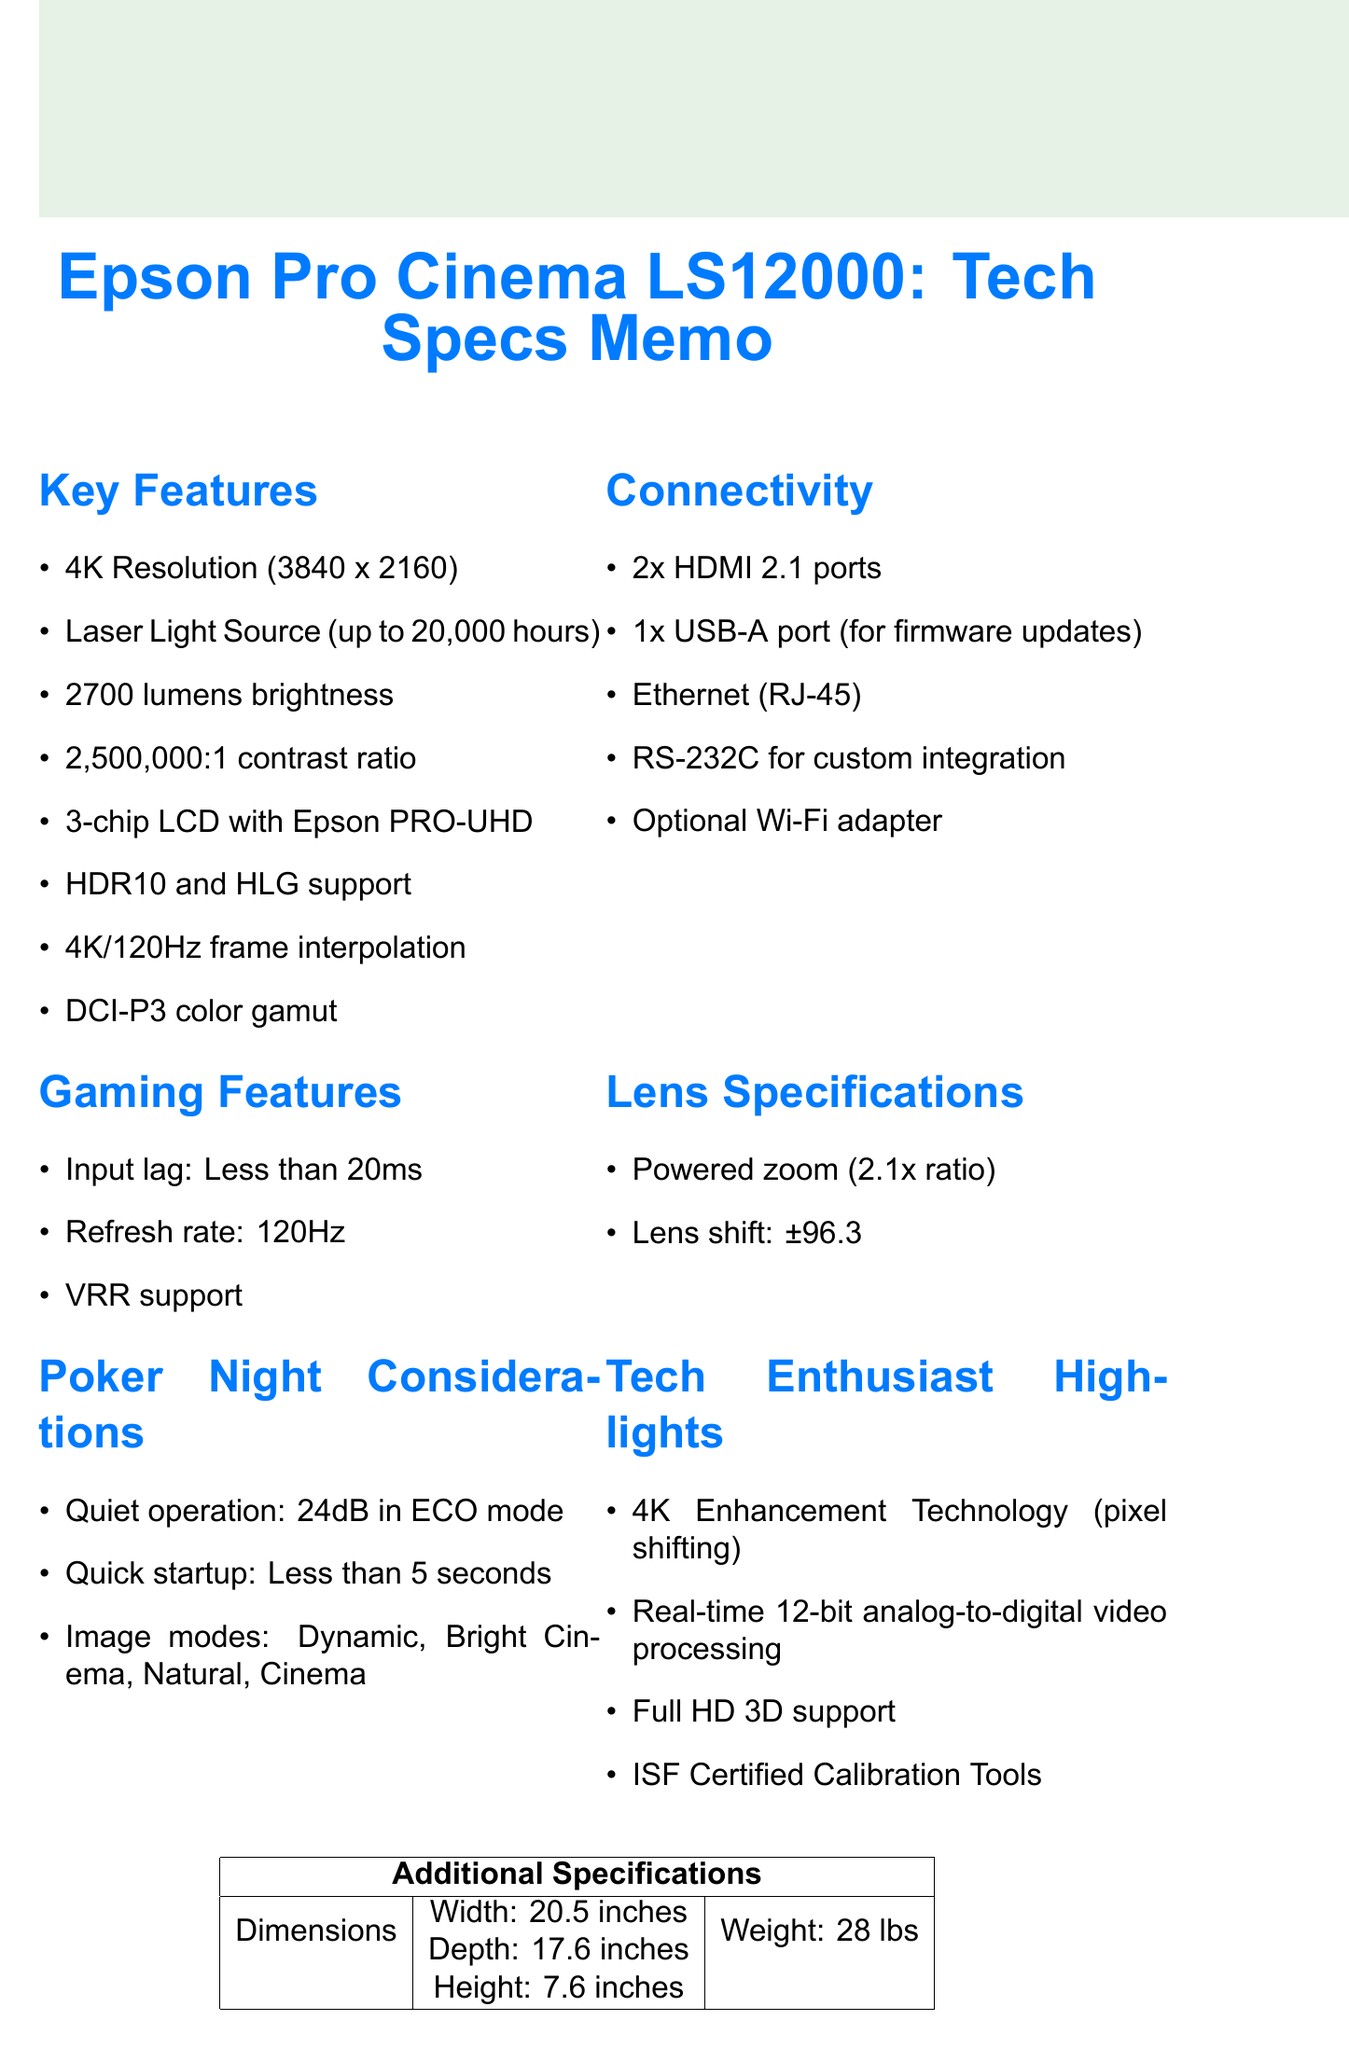What is the resolution of the projector? The resolution is explicitly stated as 4K (3840 x 2160).
Answer: 4K (3840 x 2160) How many HDMI ports does the projector have? The document notes that there are 2 HDMI 2.1 ports listed under connectivity.
Answer: 2 What is the input lag of the projector? The document mentions the input lag is less than 20ms, found in the gaming features section.
Answer: Less than 20ms What is the brightness of the projector? The brightness specification is clearly stated as 2700 lumens in the key features section.
Answer: 2700 lumens How much does the projector weigh? The weight of the projector is provided in the additional specifications table as 28 lbs.
Answer: 28 lbs What is the quiet operation noise level in ECO mode? The quiet operation noise level is indicated to be 24dB in ECO mode under poker night considerations.
Answer: 24dB What kind of audio output does the projector provide? The audio output type is a 3.5mm stereo mini-jack as stated in the audio section.
Answer: 3.5mm stereo mini-jack Which voice control systems are compatible with the projector? The document states compatibility with Google Assistant and Amazon Alexa under smart features.
Answer: Google Assistant and Amazon Alexa What is the lens shift range for this projector? The lens shift range indicates ±96.3% vertical and ±47.1% horizontal, noted in the lens specifications.
Answer: ±96.3% vertical, ±47.1% horizontal 